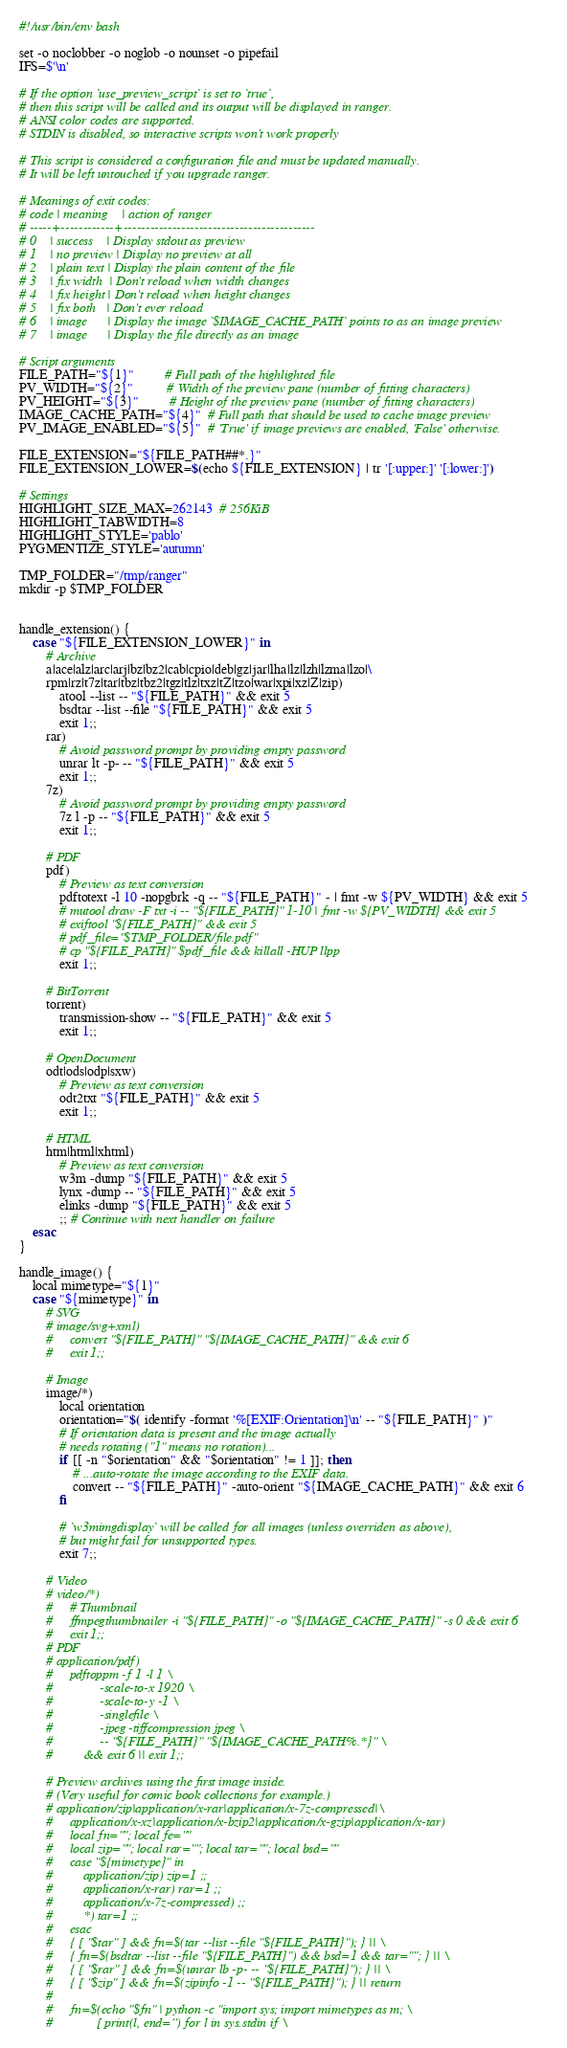Convert code to text. <code><loc_0><loc_0><loc_500><loc_500><_Bash_>#!/usr/bin/env bash

set -o noclobber -o noglob -o nounset -o pipefail
IFS=$'\n'

# If the option `use_preview_script` is set to `true`,
# then this script will be called and its output will be displayed in ranger.
# ANSI color codes are supported.
# STDIN is disabled, so interactive scripts won't work properly

# This script is considered a configuration file and must be updated manually.
# It will be left untouched if you upgrade ranger.

# Meanings of exit codes:
# code | meaning    | action of ranger
# -----+------------+-------------------------------------------
# 0    | success    | Display stdout as preview
# 1    | no preview | Display no preview at all
# 2    | plain text | Display the plain content of the file
# 3    | fix width  | Don't reload when width changes
# 4    | fix height | Don't reload when height changes
# 5    | fix both   | Don't ever reload
# 6    | image      | Display the image `$IMAGE_CACHE_PATH` points to as an image preview
# 7    | image      | Display the file directly as an image

# Script arguments
FILE_PATH="${1}"         # Full path of the highlighted file
PV_WIDTH="${2}"          # Width of the preview pane (number of fitting characters)
PV_HEIGHT="${3}"         # Height of the preview pane (number of fitting characters)
IMAGE_CACHE_PATH="${4}"  # Full path that should be used to cache image preview
PV_IMAGE_ENABLED="${5}"  # 'True' if image previews are enabled, 'False' otherwise.

FILE_EXTENSION="${FILE_PATH##*.}"
FILE_EXTENSION_LOWER=$(echo ${FILE_EXTENSION} | tr '[:upper:]' '[:lower:]')

# Settings
HIGHLIGHT_SIZE_MAX=262143  # 256KiB
HIGHLIGHT_TABWIDTH=8
HIGHLIGHT_STYLE='pablo'
PYGMENTIZE_STYLE='autumn'

TMP_FOLDER="/tmp/ranger"
mkdir -p $TMP_FOLDER


handle_extension() {
    case "${FILE_EXTENSION_LOWER}" in
        # Archive
        a|ace|alz|arc|arj|bz|bz2|cab|cpio|deb|gz|jar|lha|lz|lzh|lzma|lzo|\
        rpm|rz|t7z|tar|tbz|tbz2|tgz|tlz|txz|tZ|tzo|war|xpi|xz|Z|zip)
            atool --list -- "${FILE_PATH}" && exit 5
            bsdtar --list --file "${FILE_PATH}" && exit 5
            exit 1;;
        rar)
            # Avoid password prompt by providing empty password
            unrar lt -p- -- "${FILE_PATH}" && exit 5
            exit 1;;
        7z)
            # Avoid password prompt by providing empty password
            7z l -p -- "${FILE_PATH}" && exit 5
            exit 1;;

        # PDF
        pdf)
            # Preview as text conversion
            pdftotext -l 10 -nopgbrk -q -- "${FILE_PATH}" - | fmt -w ${PV_WIDTH} && exit 5
            # mutool draw -F txt -i -- "${FILE_PATH}" 1-10 | fmt -w ${PV_WIDTH} && exit 5
            # exiftool "${FILE_PATH}" && exit 5
            # pdf_file="$TMP_FOLDER/file.pdf"
            # cp "${FILE_PATH}" $pdf_file && killall -HUP llpp
            exit 1;;

        # BitTorrent
        torrent)
            transmission-show -- "${FILE_PATH}" && exit 5
            exit 1;;

        # OpenDocument
        odt|ods|odp|sxw)
            # Preview as text conversion
            odt2txt "${FILE_PATH}" && exit 5
            exit 1;;

        # HTML
        htm|html|xhtml)
            # Preview as text conversion
            w3m -dump "${FILE_PATH}" && exit 5
            lynx -dump -- "${FILE_PATH}" && exit 5
            elinks -dump "${FILE_PATH}" && exit 5
            ;; # Continue with next handler on failure
    esac
}

handle_image() {
    local mimetype="${1}"
    case "${mimetype}" in
        # SVG
        # image/svg+xml)
        #     convert "${FILE_PATH}" "${IMAGE_CACHE_PATH}" && exit 6
        #     exit 1;;

        # Image
        image/*)
            local orientation
            orientation="$( identify -format '%[EXIF:Orientation]\n' -- "${FILE_PATH}" )"
            # If orientation data is present and the image actually
            # needs rotating ("1" means no rotation)...
            if [[ -n "$orientation" && "$orientation" != 1 ]]; then
                # ...auto-rotate the image according to the EXIF data.
                convert -- "${FILE_PATH}" -auto-orient "${IMAGE_CACHE_PATH}" && exit 6
            fi

            # `w3mimgdisplay` will be called for all images (unless overriden as above),
            # but might fail for unsupported types.
            exit 7;;

        # Video
        # video/*)
        #     # Thumbnail
        #     ffmpegthumbnailer -i "${FILE_PATH}" -o "${IMAGE_CACHE_PATH}" -s 0 && exit 6
        #     exit 1;;
        # PDF
        # application/pdf)
        #     pdftoppm -f 1 -l 1 \
        #              -scale-to-x 1920 \
        #              -scale-to-y -1 \
        #              -singlefile \
        #              -jpeg -tiffcompression jpeg \
        #              -- "${FILE_PATH}" "${IMAGE_CACHE_PATH%.*}" \
        #         && exit 6 || exit 1;;

        # Preview archives using the first image inside.
        # (Very useful for comic book collections for example.)
        # application/zip|application/x-rar|application/x-7z-compressed|\
        #     application/x-xz|application/x-bzip2|application/x-gzip|application/x-tar)
        #     local fn=""; local fe=""
        #     local zip=""; local rar=""; local tar=""; local bsd=""
        #     case "${mimetype}" in
        #         application/zip) zip=1 ;;
        #         application/x-rar) rar=1 ;;
        #         application/x-7z-compressed) ;;
        #         *) tar=1 ;;
        #     esac
        #     { [ "$tar" ] && fn=$(tar --list --file "${FILE_PATH}"); } || \
        #     { fn=$(bsdtar --list --file "${FILE_PATH}") && bsd=1 && tar=""; } || \
        #     { [ "$rar" ] && fn=$(unrar lb -p- -- "${FILE_PATH}"); } || \
        #     { [ "$zip" ] && fn=$(zipinfo -1 -- "${FILE_PATH}"); } || return
        #
        #     fn=$(echo "$fn" | python -c "import sys; import mimetypes as m; \
        #             [ print(l, end='') for l in sys.stdin if \</code> 